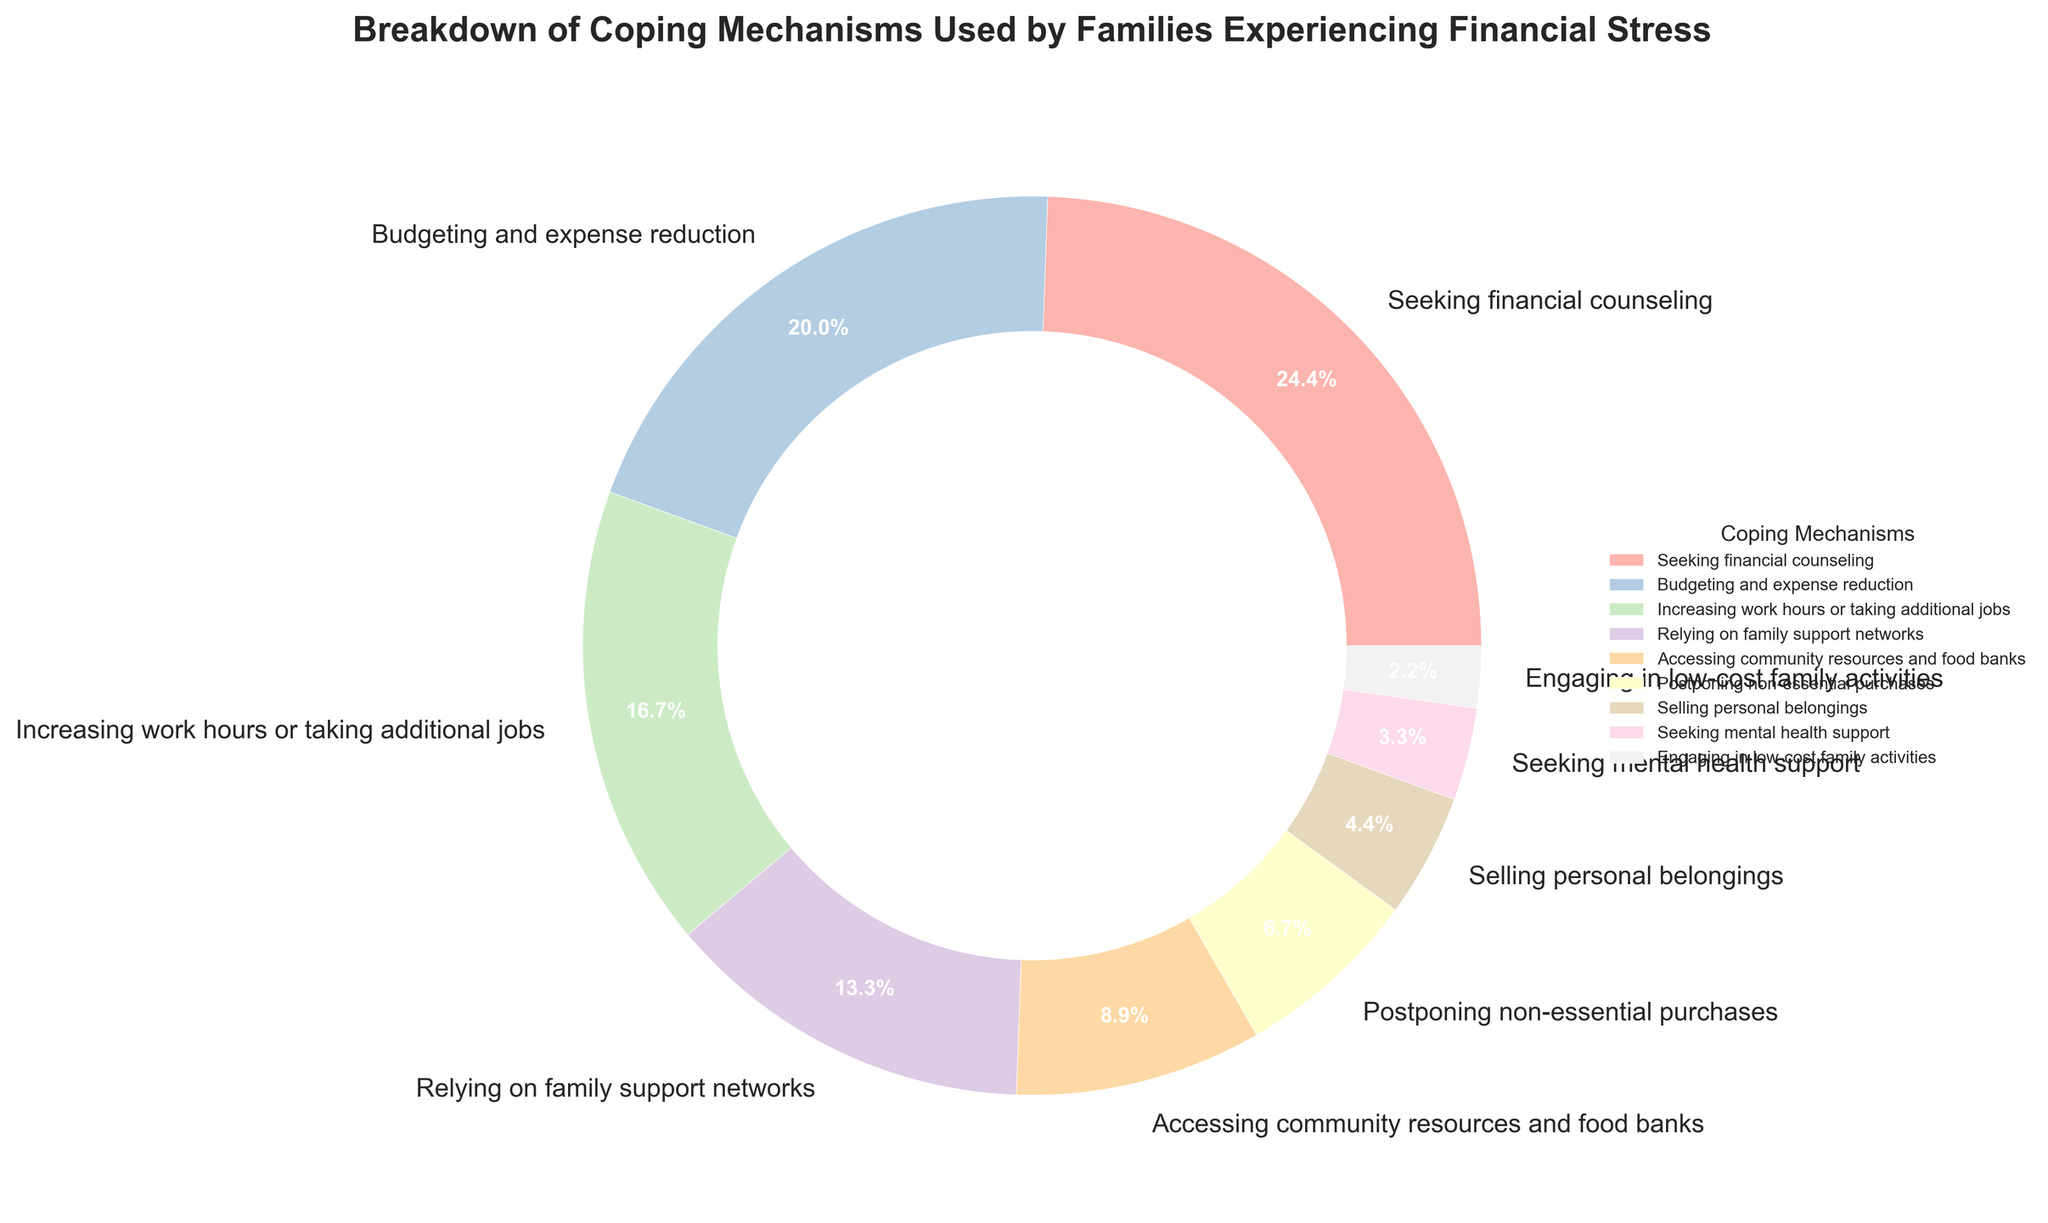Which coping mechanism is used the most by families experiencing financial stress? The largest percentage in the pie chart corresponds to "Seeking financial counseling" at 22%.
Answer: Seeking financial counseling Which two coping mechanisms combined are used by the most families? Combining the two largest percentages: "Seeking financial counseling" (22%) and "Budgeting and expense reduction" (18%), gives a total of 40%.
Answer: Seeking financial counseling and Budgeting and expense reduction What is the difference between the percentages of "Increasing work hours or taking additional jobs" and "Selling personal belongings"? The percentage for "Increasing work hours or taking additional jobs" is 15%, and the percentage for "Selling personal belongings" is 4%. Subtracting these gives 15% - 4% = 11%.
Answer: 11% How many coping mechanisms have a usage percentage of less than 10%? From the pie chart, the following mechanisms have percentages less than 10%: "Accessing community resources and food banks" (8%), "Postponing non-essential purchases" (6%), "Selling personal belongings" (4%), "Seeking mental health support" (3%), and "Engaging in low-cost family activities" (2%). There are 5 such mechanisms.
Answer: 5 Which coping mechanism has the smallest usage percentage? The smallest percentage in the pie chart corresponds to "Engaging in low-cost family activities" at 2%.
Answer: Engaging in low-cost family activities Is the percentage of families "Relying on family support networks" greater than those "Increasing work hours or taking additional jobs"? The percentage for "Relying on family support networks" is 12%, which is less than the percentage for "Increasing work hours or taking additional jobs" at 15%.
Answer: No Are there more families "Accessing community resources and food banks" than "Selling personal belongings"? The pie chart shows "Accessing community resources and food banks" at 8% and "Selling personal belongings" at 4%. Since 8% is greater than 4%, there are more families accessing community resources and food banks than selling personal belongings.
Answer: Yes What percentage of families use either "Budgeting and expense reduction" or "Increasing work hours or taking additional jobs"? The percentage for "Budgeting and expense reduction" is 18% and for "Increasing work hours or taking additional jobs" is 15%. Adding these gives 18% + 15% = 33%.
Answer: 33% Which coping mechanisms have equal usage percentages of less than 5%? The pie chart indicates that "Selling personal belongings" (4%) and "Seeking mental health support" (3%) have percentages less than 5%. They do not have equal percentages, so there are none with exactly equal percentages.
Answer: None Do more families "Postpone non-essential purchases" or "Rely on family support networks"? The percentage for "Postponing non-essential purchases" is 6%, while "Relying on family support networks" has a percentage of 12%. Since 12% is greater than 6%, more families rely on family support networks.
Answer: Rely on family support networks 